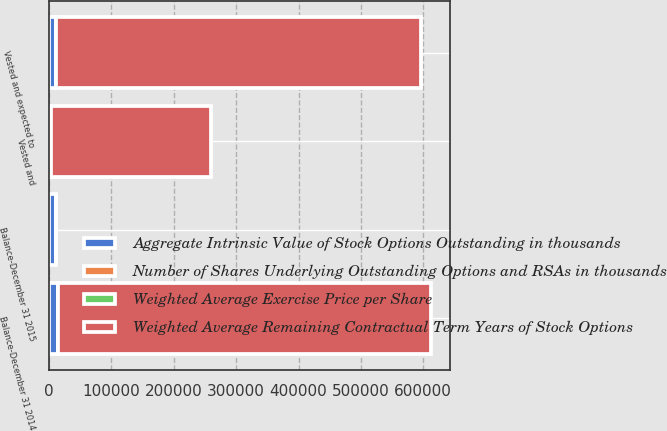Convert chart. <chart><loc_0><loc_0><loc_500><loc_500><stacked_bar_chart><ecel><fcel>Balance-December 31 2014<fcel>Balance-December 31 2015<fcel>Vested and<fcel>Vested and expected to<nl><fcel>Aggregate Intrinsic Value of Stock Options Outstanding in thousands<fcel>13654<fcel>11630<fcel>3692<fcel>10786<nl><fcel>Number of Shares Underlying Outstanding Options and RSAs in thousands<fcel>17.63<fcel>24.49<fcel>8.68<fcel>23.57<nl><fcel>Weighted Average Exercise Price per Share<fcel>8.3<fcel>7.6<fcel>6.64<fcel>7.58<nl><fcel>Weighted Average Remaining Contractual Term Years of Stock Options<fcel>598775<fcel>24.49<fcel>255392<fcel>585727<nl></chart> 